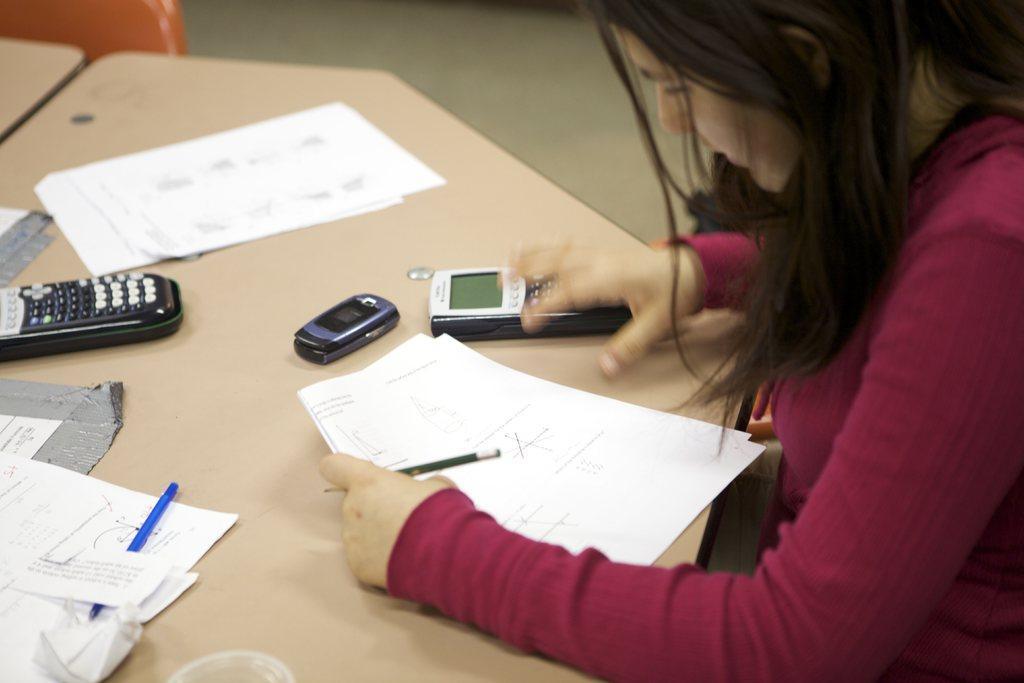Can you describe this image briefly? In this picture I can see papers, there is a mobile, pen, there are calculators and an object on the table, there is a person holding papers and a pencil, and in the background there is another table, and it is looking like a chair. 